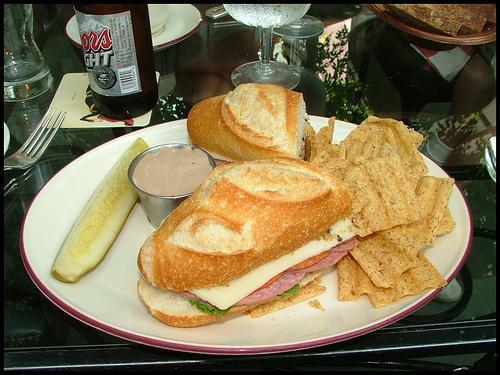How many sandwiches are in the photo?
Give a very brief answer. 2. How many cups are there?
Give a very brief answer. 1. How many bowls can be seen?
Give a very brief answer. 2. How many people are wearing brown shirts?
Give a very brief answer. 0. 